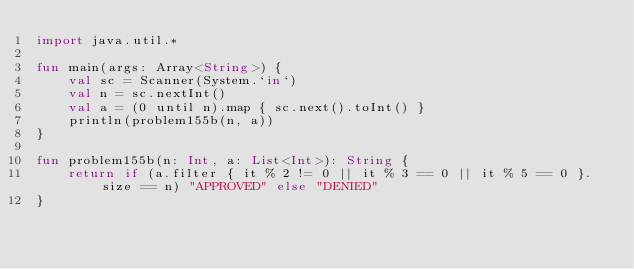<code> <loc_0><loc_0><loc_500><loc_500><_Kotlin_>import java.util.*

fun main(args: Array<String>) {
    val sc = Scanner(System.`in`)
    val n = sc.nextInt()
    val a = (0 until n).map { sc.next().toInt() }
    println(problem155b(n, a))
}

fun problem155b(n: Int, a: List<Int>): String {
    return if (a.filter { it % 2 != 0 || it % 3 == 0 || it % 5 == 0 }.size == n) "APPROVED" else "DENIED"
}</code> 